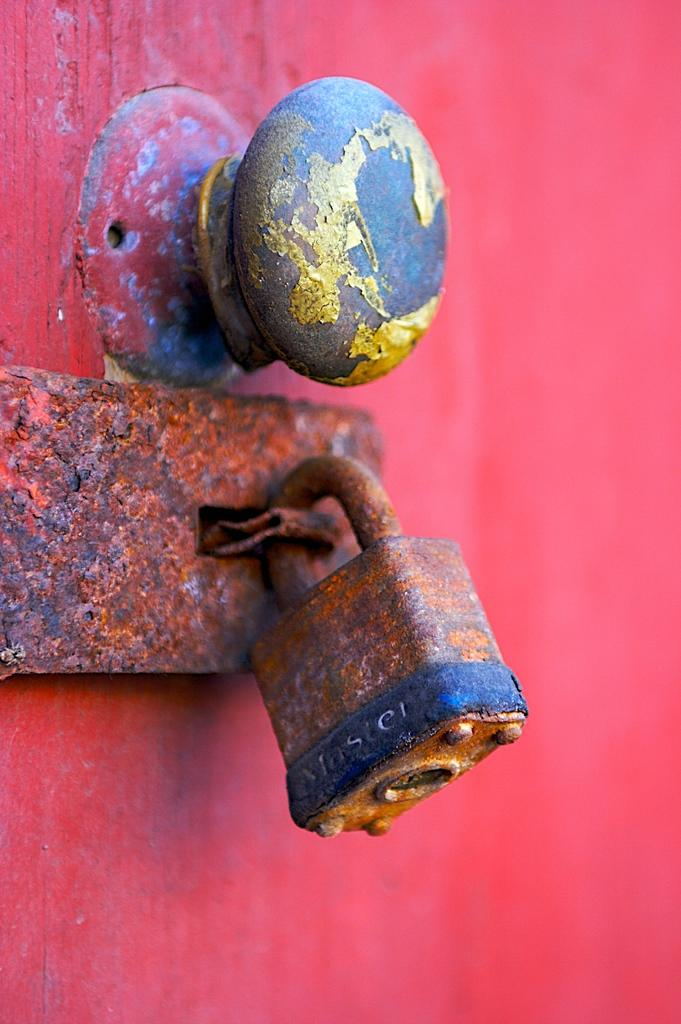What can be found on the door in the image? There is a door handle and a lock on the left side of the door in the image. Is there any additional security feature on the door? Yes, there is a lock aldrop on the left side of the door. What type of cactus is growing on the door in the image? There is no cactus present on the door in the image. What material is the door handle made of, such as copper? The material of the door handle is not mentioned in the provided facts, so it cannot be determined from the image. 